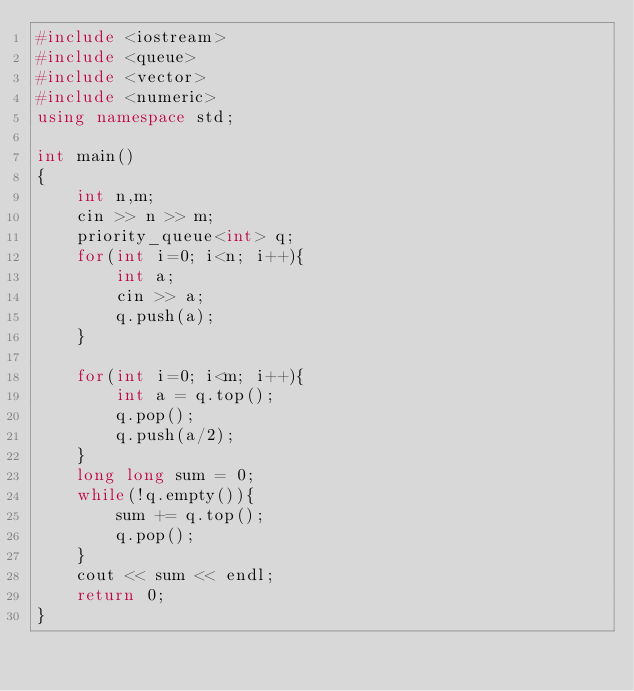<code> <loc_0><loc_0><loc_500><loc_500><_C++_>#include <iostream>
#include <queue>
#include <vector>
#include <numeric>
using namespace std;

int main()
{
    int n,m;
    cin >> n >> m;
    priority_queue<int> q;
    for(int i=0; i<n; i++){
        int a;
        cin >> a;
        q.push(a);
    }

    for(int i=0; i<m; i++){
        int a = q.top();
        q.pop();
        q.push(a/2);
    }
    long long sum = 0;
    while(!q.empty()){
        sum += q.top();
        q.pop();
    }
    cout << sum << endl;
    return 0;
}</code> 